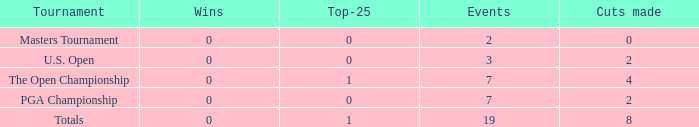How many wins do the top 25 competitors have in events 1 and 7? 0.0. I'm looking to parse the entire table for insights. Could you assist me with that? {'header': ['Tournament', 'Wins', 'Top-25', 'Events', 'Cuts made'], 'rows': [['Masters Tournament', '0', '0', '2', '0'], ['U.S. Open', '0', '0', '3', '2'], ['The Open Championship', '0', '1', '7', '4'], ['PGA Championship', '0', '0', '7', '2'], ['Totals', '0', '1', '19', '8']]} 